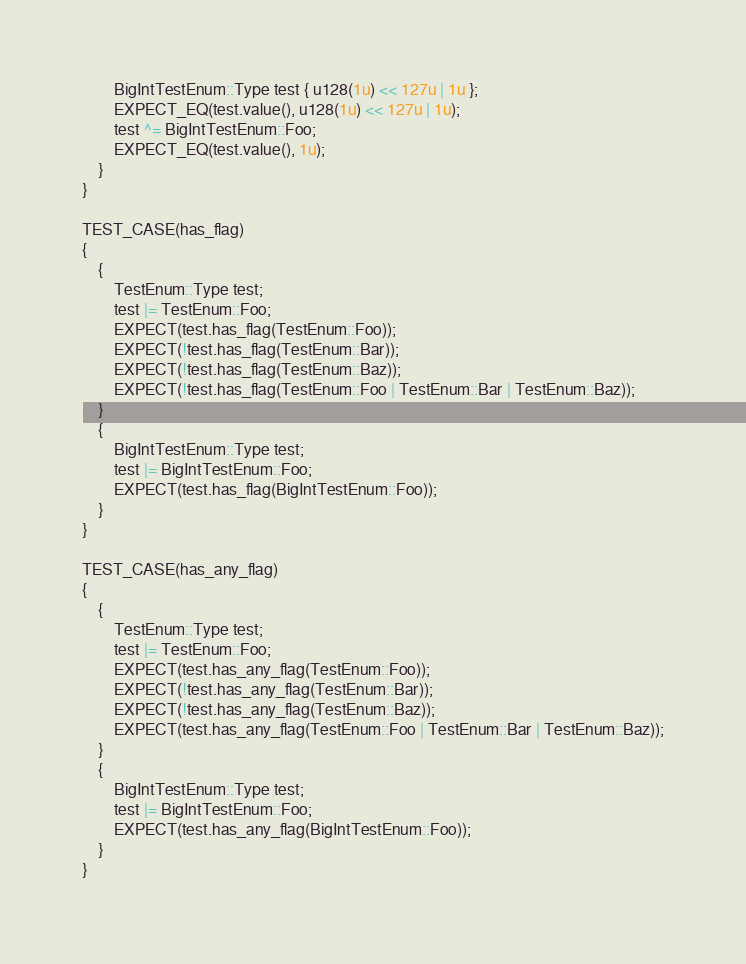<code> <loc_0><loc_0><loc_500><loc_500><_C++_>        BigIntTestEnum::Type test { u128(1u) << 127u | 1u };
        EXPECT_EQ(test.value(), u128(1u) << 127u | 1u);
        test ^= BigIntTestEnum::Foo;
        EXPECT_EQ(test.value(), 1u);
    }
}

TEST_CASE(has_flag)
{
    {
        TestEnum::Type test;
        test |= TestEnum::Foo;
        EXPECT(test.has_flag(TestEnum::Foo));
        EXPECT(!test.has_flag(TestEnum::Bar));
        EXPECT(!test.has_flag(TestEnum::Baz));
        EXPECT(!test.has_flag(TestEnum::Foo | TestEnum::Bar | TestEnum::Baz));
    }
    {
        BigIntTestEnum::Type test;
        test |= BigIntTestEnum::Foo;
        EXPECT(test.has_flag(BigIntTestEnum::Foo));
    }
}

TEST_CASE(has_any_flag)
{
    {
        TestEnum::Type test;
        test |= TestEnum::Foo;
        EXPECT(test.has_any_flag(TestEnum::Foo));
        EXPECT(!test.has_any_flag(TestEnum::Bar));
        EXPECT(!test.has_any_flag(TestEnum::Baz));
        EXPECT(test.has_any_flag(TestEnum::Foo | TestEnum::Bar | TestEnum::Baz));
    }
    {
        BigIntTestEnum::Type test;
        test |= BigIntTestEnum::Foo;
        EXPECT(test.has_any_flag(BigIntTestEnum::Foo));
    }
}
</code> 